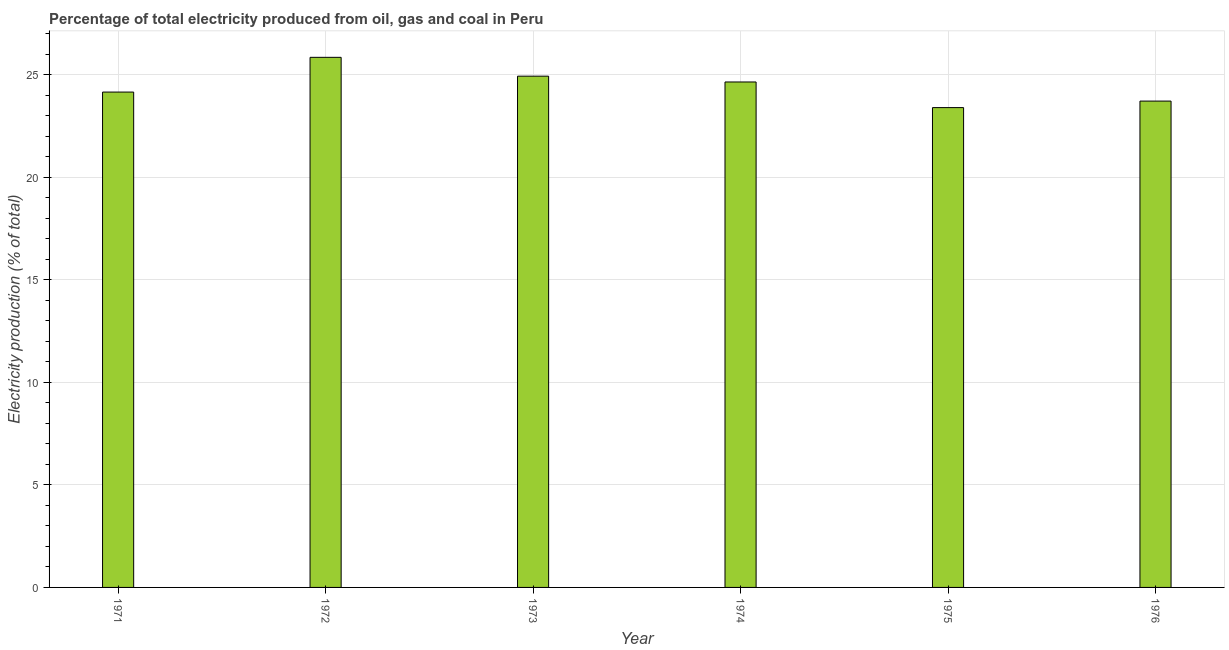Does the graph contain any zero values?
Give a very brief answer. No. What is the title of the graph?
Your response must be concise. Percentage of total electricity produced from oil, gas and coal in Peru. What is the label or title of the X-axis?
Provide a short and direct response. Year. What is the label or title of the Y-axis?
Offer a very short reply. Electricity production (% of total). What is the electricity production in 1974?
Offer a terse response. 24.66. Across all years, what is the maximum electricity production?
Your answer should be very brief. 25.86. Across all years, what is the minimum electricity production?
Give a very brief answer. 23.41. In which year was the electricity production minimum?
Your answer should be compact. 1975. What is the sum of the electricity production?
Ensure brevity in your answer.  146.75. What is the difference between the electricity production in 1972 and 1975?
Make the answer very short. 2.45. What is the average electricity production per year?
Offer a terse response. 24.46. What is the median electricity production?
Keep it short and to the point. 24.41. What is the difference between the highest and the second highest electricity production?
Make the answer very short. 0.92. Is the sum of the electricity production in 1972 and 1974 greater than the maximum electricity production across all years?
Provide a succinct answer. Yes. What is the difference between the highest and the lowest electricity production?
Make the answer very short. 2.45. In how many years, is the electricity production greater than the average electricity production taken over all years?
Offer a terse response. 3. How many bars are there?
Ensure brevity in your answer.  6. What is the Electricity production (% of total) of 1971?
Keep it short and to the point. 24.16. What is the Electricity production (% of total) of 1972?
Your response must be concise. 25.86. What is the Electricity production (% of total) of 1973?
Keep it short and to the point. 24.94. What is the Electricity production (% of total) of 1974?
Your response must be concise. 24.66. What is the Electricity production (% of total) in 1975?
Your answer should be compact. 23.41. What is the Electricity production (% of total) of 1976?
Your answer should be very brief. 23.72. What is the difference between the Electricity production (% of total) in 1971 and 1972?
Offer a terse response. -1.69. What is the difference between the Electricity production (% of total) in 1971 and 1973?
Provide a short and direct response. -0.78. What is the difference between the Electricity production (% of total) in 1971 and 1974?
Make the answer very short. -0.49. What is the difference between the Electricity production (% of total) in 1971 and 1975?
Provide a short and direct response. 0.76. What is the difference between the Electricity production (% of total) in 1971 and 1976?
Make the answer very short. 0.44. What is the difference between the Electricity production (% of total) in 1972 and 1973?
Offer a terse response. 0.92. What is the difference between the Electricity production (% of total) in 1972 and 1974?
Ensure brevity in your answer.  1.2. What is the difference between the Electricity production (% of total) in 1972 and 1975?
Ensure brevity in your answer.  2.45. What is the difference between the Electricity production (% of total) in 1972 and 1976?
Your answer should be compact. 2.13. What is the difference between the Electricity production (% of total) in 1973 and 1974?
Offer a very short reply. 0.28. What is the difference between the Electricity production (% of total) in 1973 and 1975?
Your response must be concise. 1.53. What is the difference between the Electricity production (% of total) in 1973 and 1976?
Offer a terse response. 1.22. What is the difference between the Electricity production (% of total) in 1974 and 1975?
Ensure brevity in your answer.  1.25. What is the difference between the Electricity production (% of total) in 1974 and 1976?
Give a very brief answer. 0.93. What is the difference between the Electricity production (% of total) in 1975 and 1976?
Your answer should be very brief. -0.32. What is the ratio of the Electricity production (% of total) in 1971 to that in 1972?
Ensure brevity in your answer.  0.93. What is the ratio of the Electricity production (% of total) in 1971 to that in 1973?
Provide a succinct answer. 0.97. What is the ratio of the Electricity production (% of total) in 1971 to that in 1974?
Your answer should be very brief. 0.98. What is the ratio of the Electricity production (% of total) in 1971 to that in 1975?
Keep it short and to the point. 1.03. What is the ratio of the Electricity production (% of total) in 1971 to that in 1976?
Make the answer very short. 1.02. What is the ratio of the Electricity production (% of total) in 1972 to that in 1973?
Provide a short and direct response. 1.04. What is the ratio of the Electricity production (% of total) in 1972 to that in 1974?
Give a very brief answer. 1.05. What is the ratio of the Electricity production (% of total) in 1972 to that in 1975?
Your response must be concise. 1.1. What is the ratio of the Electricity production (% of total) in 1972 to that in 1976?
Provide a short and direct response. 1.09. What is the ratio of the Electricity production (% of total) in 1973 to that in 1974?
Offer a terse response. 1.01. What is the ratio of the Electricity production (% of total) in 1973 to that in 1975?
Your response must be concise. 1.06. What is the ratio of the Electricity production (% of total) in 1973 to that in 1976?
Keep it short and to the point. 1.05. What is the ratio of the Electricity production (% of total) in 1974 to that in 1975?
Offer a very short reply. 1.05. What is the ratio of the Electricity production (% of total) in 1974 to that in 1976?
Provide a succinct answer. 1.04. What is the ratio of the Electricity production (% of total) in 1975 to that in 1976?
Provide a short and direct response. 0.99. 